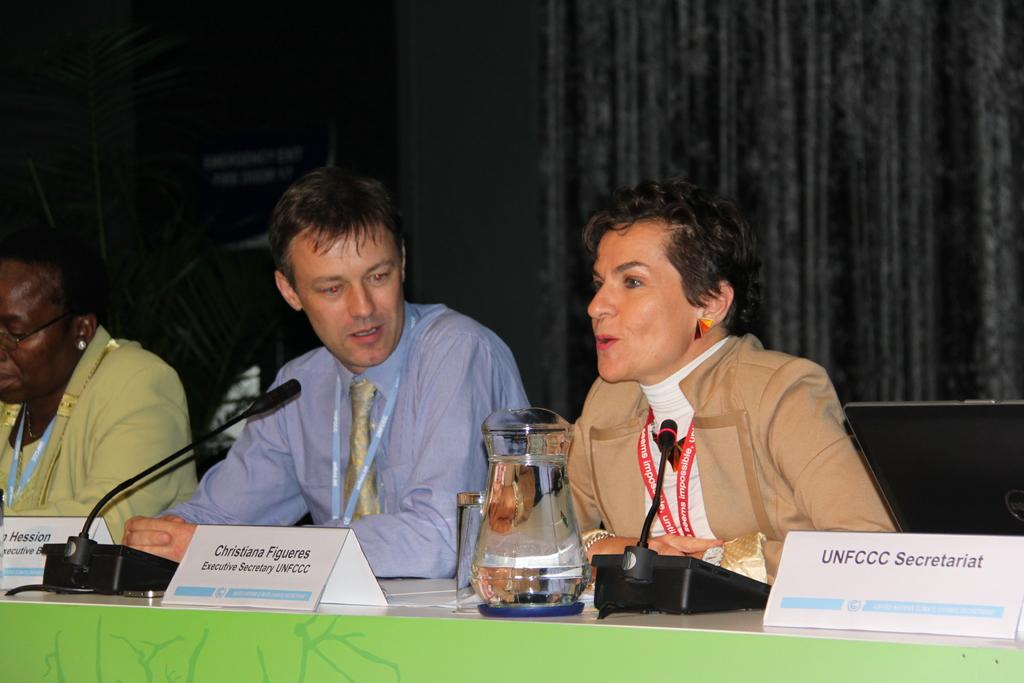How many people are seated in the image? There are three people seated in the image. What is in front of the seated people? There is a table in front of the people. What objects can be seen on the table? There is a jug and a microphone on the table. What additional detail can be seen on the table? There are name plates on the table. What is written on the name plates? The name plates have "UNFCCC Secretariat" written on them. What type of leather material is covering the star in the image? There is no star or leather material present in the image. 